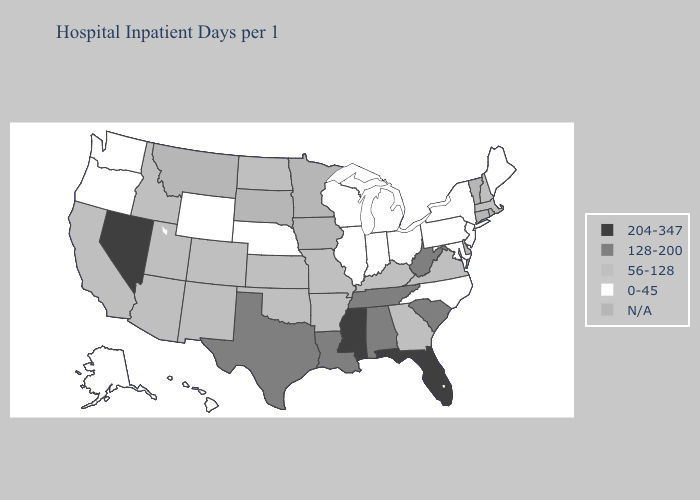Name the states that have a value in the range 204-347?
Give a very brief answer. Florida, Mississippi, Nevada. Does Colorado have the lowest value in the USA?
Write a very short answer. No. Name the states that have a value in the range N/A?
Answer briefly. Connecticut, Delaware, Iowa, Minnesota, Montana, Rhode Island, South Dakota, Vermont. What is the highest value in the USA?
Answer briefly. 204-347. Among the states that border Kentucky , does West Virginia have the highest value?
Give a very brief answer. Yes. Which states have the highest value in the USA?
Quick response, please. Florida, Mississippi, Nevada. Name the states that have a value in the range 204-347?
Answer briefly. Florida, Mississippi, Nevada. Name the states that have a value in the range 56-128?
Write a very short answer. Arizona, Arkansas, California, Colorado, Georgia, Idaho, Kansas, Kentucky, Massachusetts, Missouri, New Hampshire, New Mexico, North Dakota, Oklahoma, Utah, Virginia. Name the states that have a value in the range 204-347?
Be succinct. Florida, Mississippi, Nevada. What is the value of Colorado?
Quick response, please. 56-128. Name the states that have a value in the range 0-45?
Be succinct. Alaska, Hawaii, Illinois, Indiana, Maine, Maryland, Michigan, Nebraska, New Jersey, New York, North Carolina, Ohio, Oregon, Pennsylvania, Washington, Wisconsin, Wyoming. What is the lowest value in the USA?
Answer briefly. 0-45. Name the states that have a value in the range 0-45?
Concise answer only. Alaska, Hawaii, Illinois, Indiana, Maine, Maryland, Michigan, Nebraska, New Jersey, New York, North Carolina, Ohio, Oregon, Pennsylvania, Washington, Wisconsin, Wyoming. What is the highest value in states that border Colorado?
Quick response, please. 56-128. Does Florida have the highest value in the USA?
Write a very short answer. Yes. 